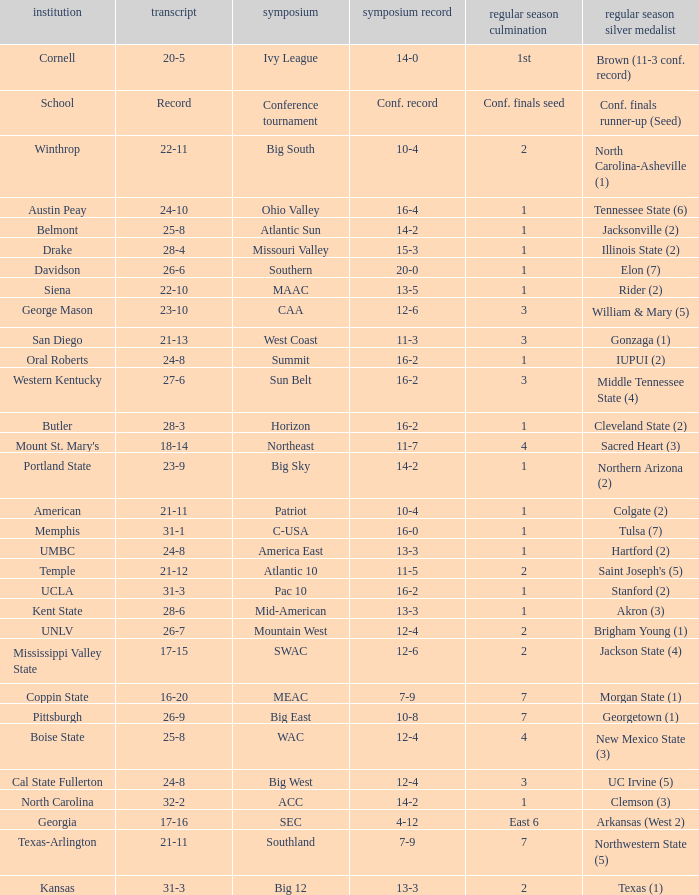Which qualifying schools were in the Patriot conference? American. 